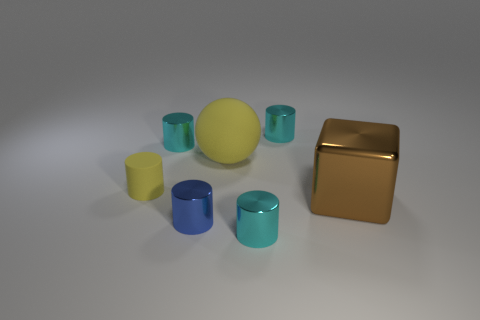Subtract all tiny matte cylinders. How many cylinders are left? 4 How many cyan cylinders must be subtracted to get 1 cyan cylinders? 2 Subtract all cyan cylinders. How many cylinders are left? 2 Subtract all balls. How many objects are left? 6 Subtract 1 cubes. How many cubes are left? 0 Subtract all gray cubes. Subtract all green cylinders. How many cubes are left? 1 Subtract all cyan cylinders. How many green balls are left? 0 Subtract all blue cylinders. Subtract all small shiny objects. How many objects are left? 2 Add 3 cyan metallic cylinders. How many cyan metallic cylinders are left? 6 Add 1 small red rubber things. How many small red rubber things exist? 1 